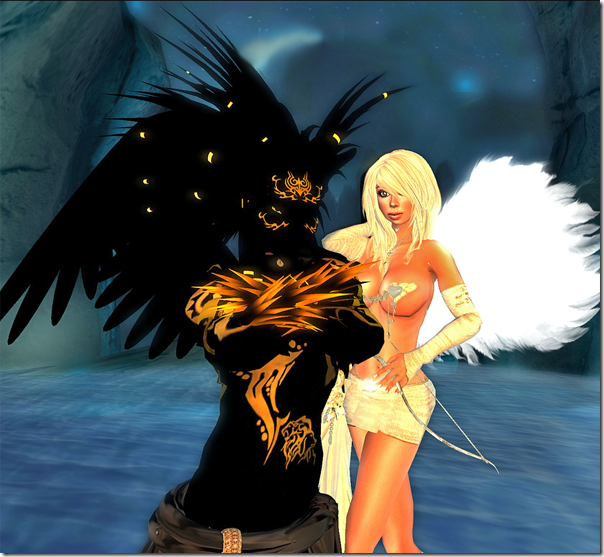How do the elements of light and darkness in the character design play into the overall theme of the image? The stark contrast between light and darkness in the character designs serves to not only enhance their visual impact but also symbolize thematic opposites such as good versus evil or purity versus corruption. The character adorned in bright attire with white wings could be seen as embodying purity or celestial goodness, while the character dressed in dark with black wings might represent shadow or mystical power. This dynamic could hint at underlying themes of balance, conflict, or harmony between opposing forces within the narrative suggested by the image. 